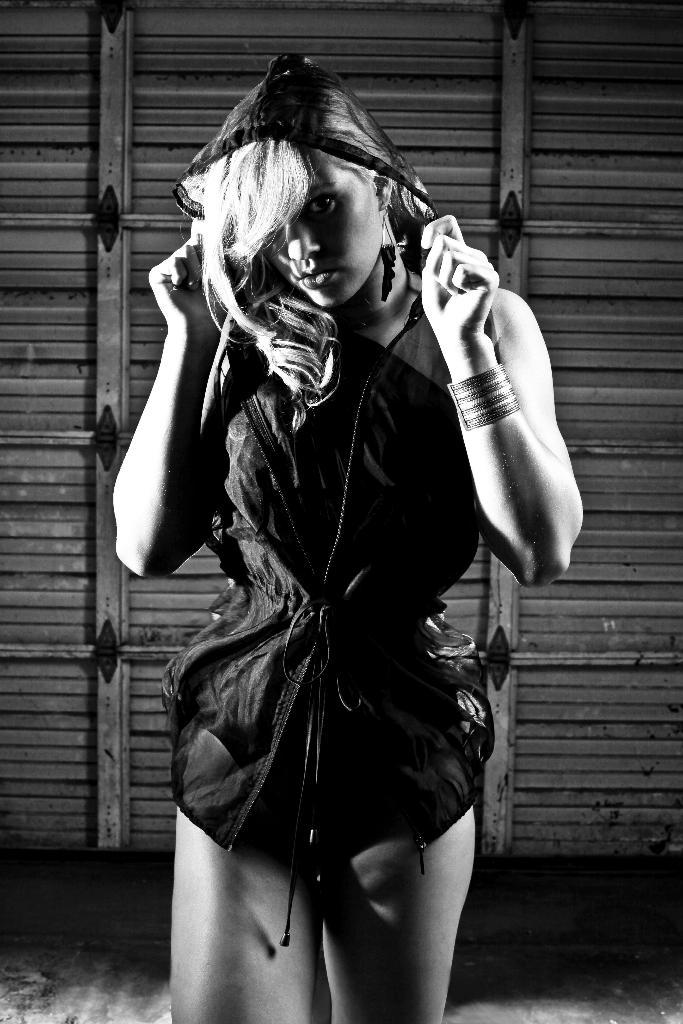What is the color scheme of the image? The image is in black and white. Who is present in the image? There is a woman in the image. What is the woman wearing? The woman is wearing a black dress. What is the woman doing in the image? The woman is standing. What can be seen in the background of the image? There is a wooden wall in the background of the image. How does the woman's digestion process appear in the image? The image does not show the woman's digestion process; it only shows her standing in a black dress. What part of the woman's hands can be seen in the image? The image does not show any part of the woman's hands; it only shows her standing in a black dress. 